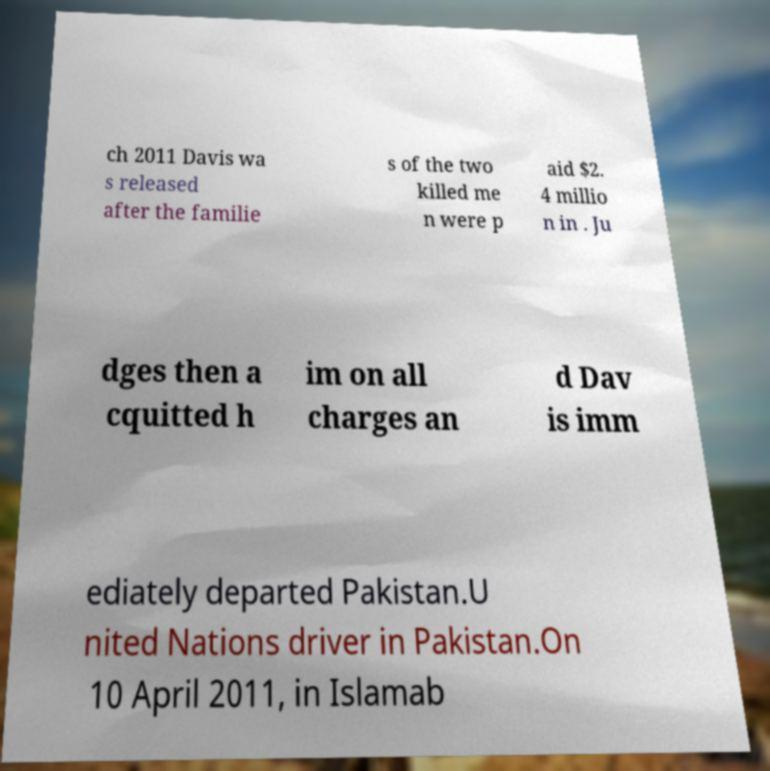What messages or text are displayed in this image? I need them in a readable, typed format. ch 2011 Davis wa s released after the familie s of the two killed me n were p aid $2. 4 millio n in . Ju dges then a cquitted h im on all charges an d Dav is imm ediately departed Pakistan.U nited Nations driver in Pakistan.On 10 April 2011, in Islamab 